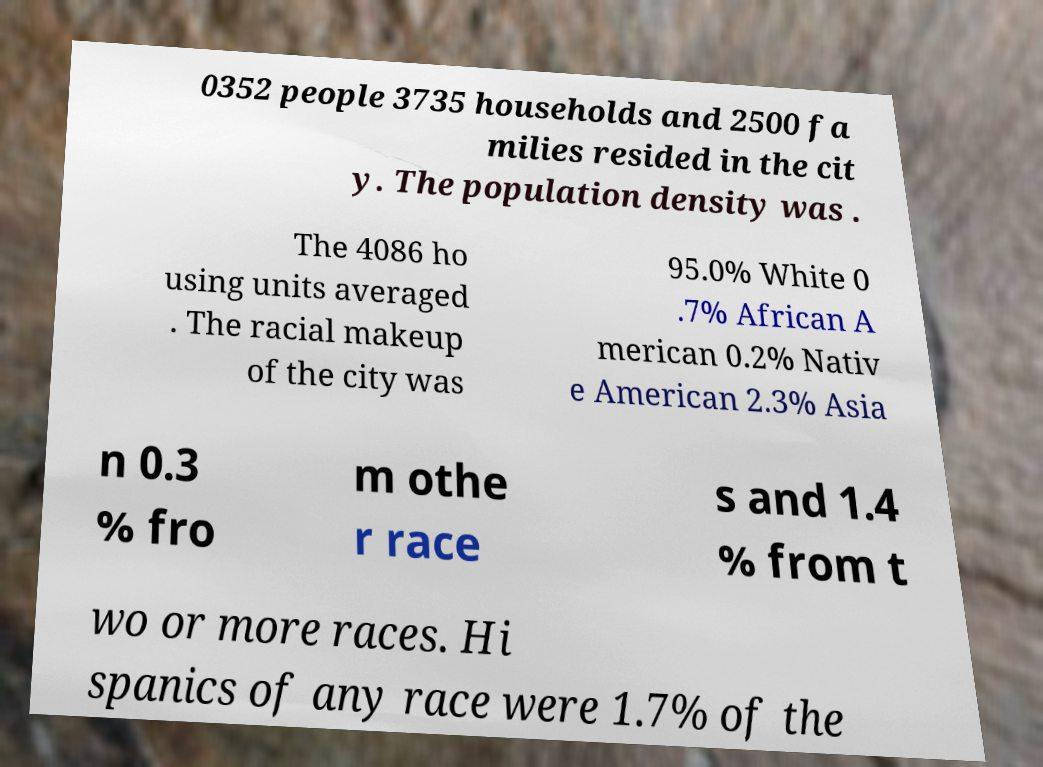What messages or text are displayed in this image? I need them in a readable, typed format. 0352 people 3735 households and 2500 fa milies resided in the cit y. The population density was . The 4086 ho using units averaged . The racial makeup of the city was 95.0% White 0 .7% African A merican 0.2% Nativ e American 2.3% Asia n 0.3 % fro m othe r race s and 1.4 % from t wo or more races. Hi spanics of any race were 1.7% of the 